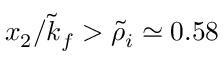<formula> <loc_0><loc_0><loc_500><loc_500>x _ { 2 } / \tilde { k } _ { f } > \tilde { \rho } _ { i } \simeq 0 . 5 8</formula> 